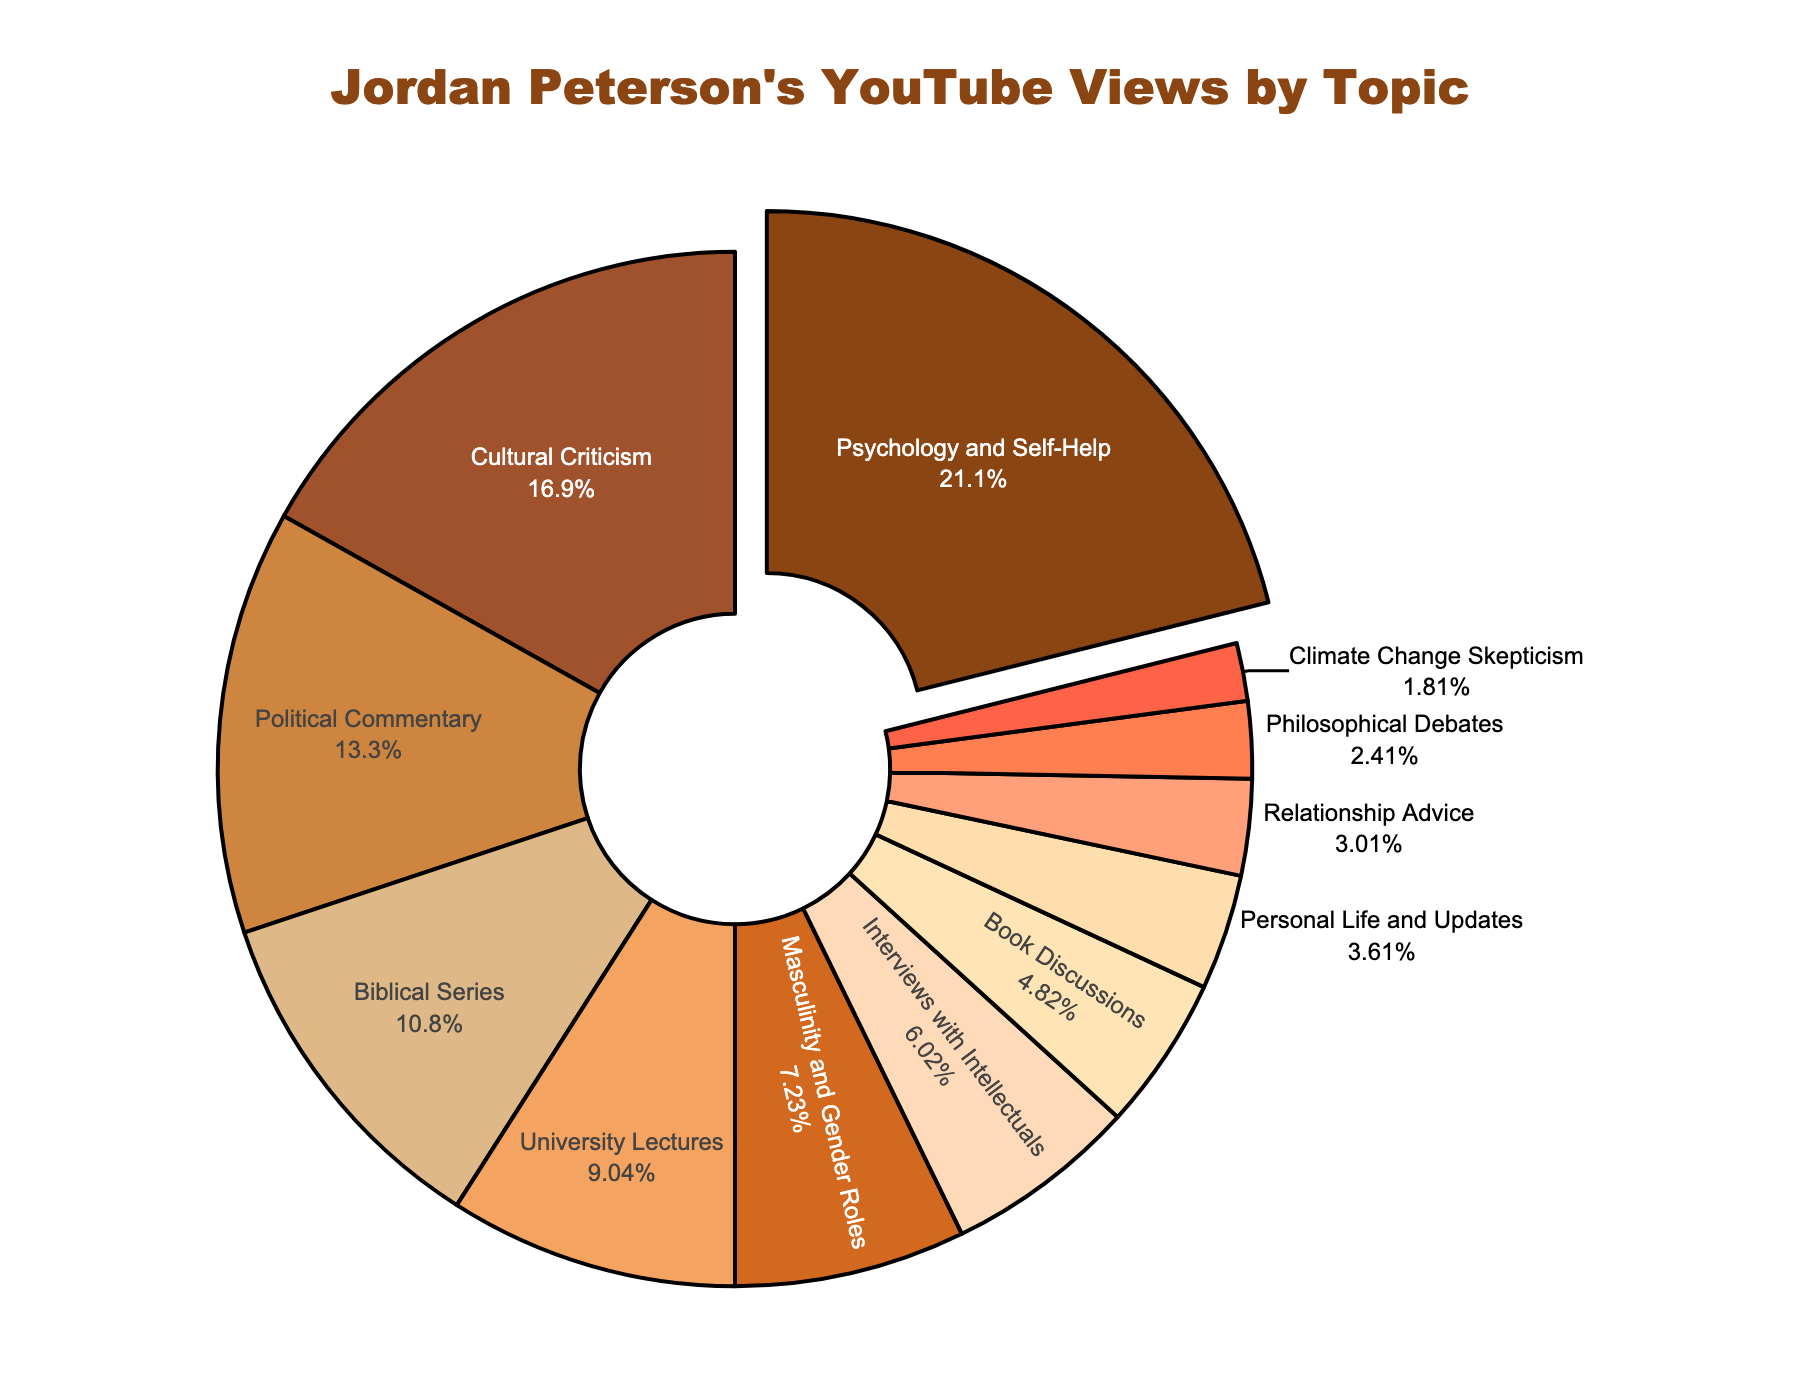What's the largest topic by the number of views? The largest segment in the pie chart represents "Psychology and Self-Help". This segment is visually distinguished because it is slightly pulled out from the rest and has the largest area.
Answer: Psychology and Self-Help Which topic has the lowest number of views? The smallest segment by area in the pie chart represents "Climate Change Skepticism".
Answer: Climate Change Skepticism How many views do the top 3 topics account for together? The top three topics are "Psychology and Self-Help" (35,000,000), "Cultural Criticism" (28,000,000), and "Political Commentary" (22,000,000). Summing these values: 35,000,000 + 28,000,000 + 22,000,000 = 85,000,000.
Answer: 85,000,000 Which has more views: "Political Commentary" or "University Lectures"? By comparing their sizes, it is clear that "Political Commentary" (22,000,000) has more views than "University Lectures" (15,000,000).
Answer: Political Commentary What is the percentage of views for the "Biblical Series" topic? The pie chart provides the percentage for each segment. The "Biblical Series" accounts for 15.5% of the views.
Answer: 15.5% In terms of views, how does "Interviews with Intellectuals" compare to "Masculinity and Gender Roles"? "Interviews with Intellectuals" (10,000,000 views) is less than "Masculinity and Gender Roles" (12,000,000 views), as indicated by their relative sizes.
Answer: Less How many more views does "Cultural Criticism" have compared to "Personal Life and Updates"? "Cultural Criticism" has 28,000,000 views and "Personal Life and Updates" has 6,000,000 views. The difference is 28,000,000 - 6,000,000 = 22,000,000.
Answer: 22,000,000 What is the combined percentage of views for topics related to "Relationship Advice" and "Philosophical Debates"? The "Relationship Advice" segment represents 4.3%, and the "Philosophical Debates" segment represents 3.4%. Adding these percentages: 4.3% + 3.4% = 7.7%.
Answer: 7.7% Which color represents the "Climate Change Skepticism" topic in the chart? The segment for "Climate Change Skepticism" is colored in a shade of tomato red.
Answer: Tomato red 